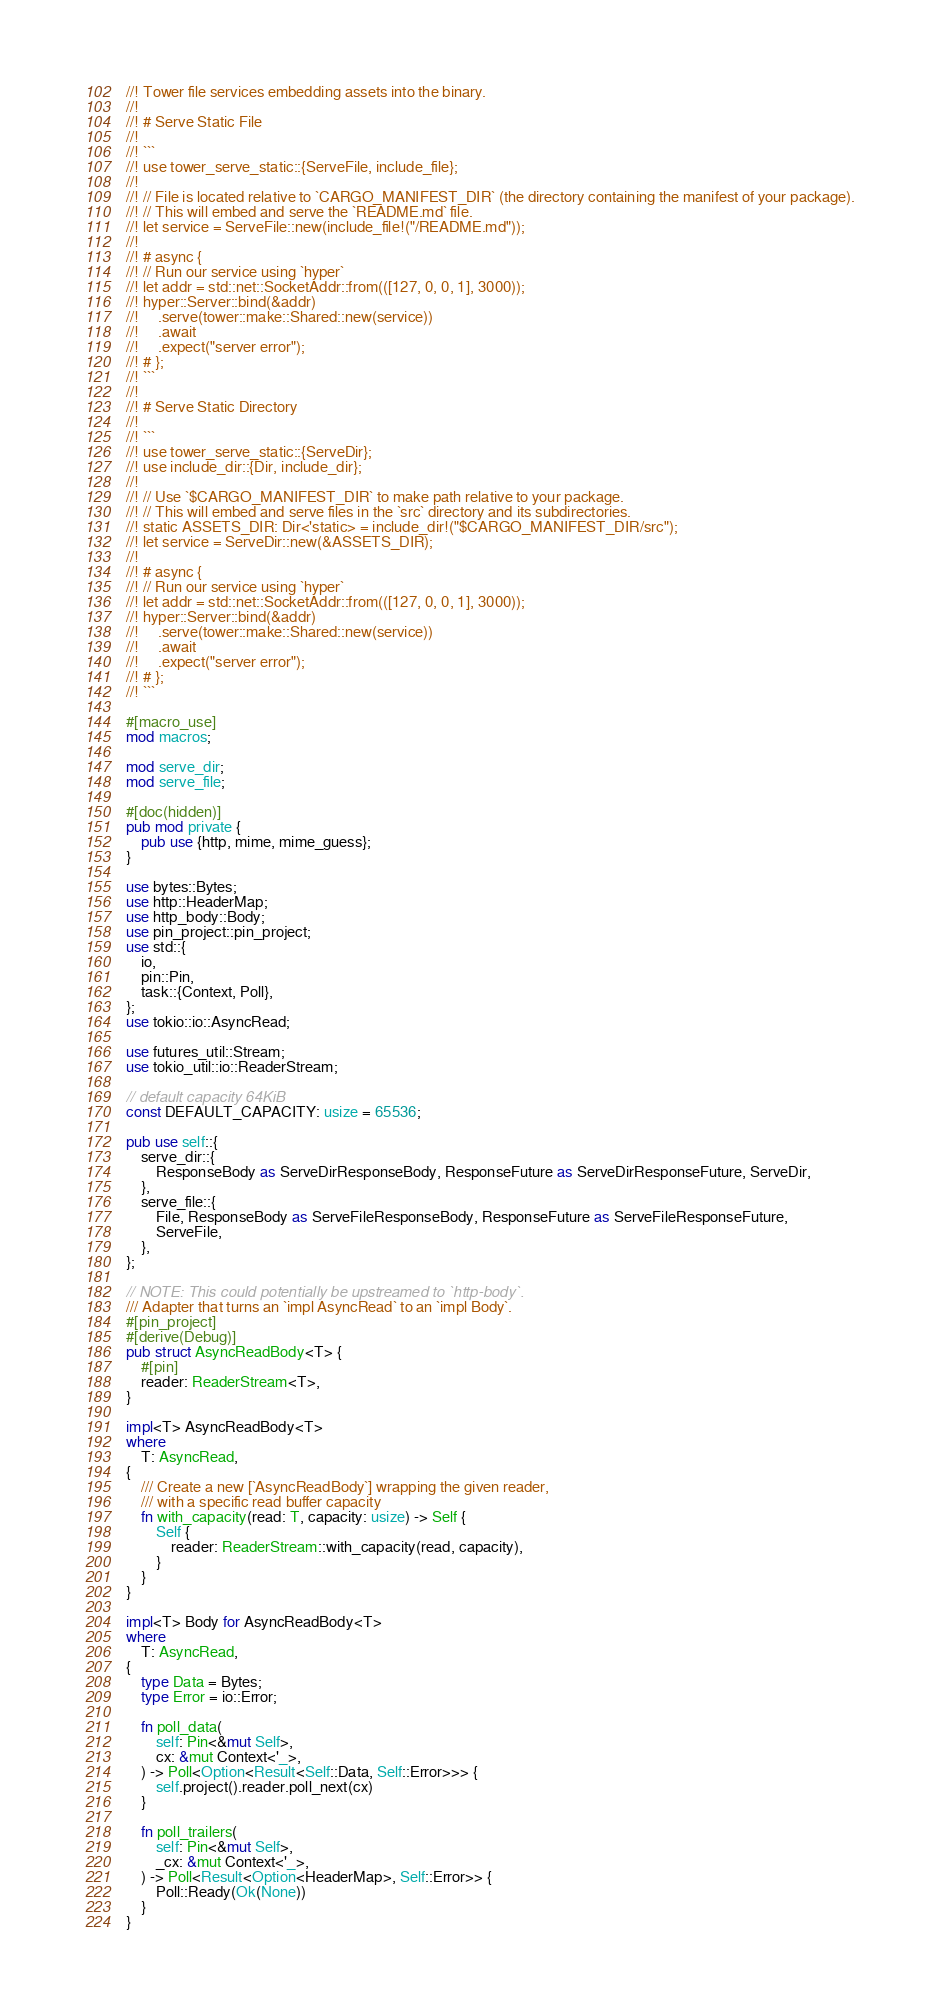Convert code to text. <code><loc_0><loc_0><loc_500><loc_500><_Rust_>//! Tower file services embedding assets into the binary.
//!
//! # Serve Static File
//!
//! ```
//! use tower_serve_static::{ServeFile, include_file};
//!
//! // File is located relative to `CARGO_MANIFEST_DIR` (the directory containing the manifest of your package).
//! // This will embed and serve the `README.md` file.
//! let service = ServeFile::new(include_file!("/README.md"));
//!
//! # async {
//! // Run our service using `hyper`
//! let addr = std::net::SocketAddr::from(([127, 0, 0, 1], 3000));
//! hyper::Server::bind(&addr)
//!     .serve(tower::make::Shared::new(service))
//!     .await
//!     .expect("server error");
//! # };
//! ```
//!
//! # Serve Static Directory
//!
//! ```
//! use tower_serve_static::{ServeDir};
//! use include_dir::{Dir, include_dir};
//!
//! // Use `$CARGO_MANIFEST_DIR` to make path relative to your package.
//! // This will embed and serve files in the `src` directory and its subdirectories.
//! static ASSETS_DIR: Dir<'static> = include_dir!("$CARGO_MANIFEST_DIR/src");
//! let service = ServeDir::new(&ASSETS_DIR);
//!
//! # async {
//! // Run our service using `hyper`
//! let addr = std::net::SocketAddr::from(([127, 0, 0, 1], 3000));
//! hyper::Server::bind(&addr)
//!     .serve(tower::make::Shared::new(service))
//!     .await
//!     .expect("server error");
//! # };
//! ```

#[macro_use]
mod macros;

mod serve_dir;
mod serve_file;

#[doc(hidden)]
pub mod private {
    pub use {http, mime, mime_guess};
}

use bytes::Bytes;
use http::HeaderMap;
use http_body::Body;
use pin_project::pin_project;
use std::{
    io,
    pin::Pin,
    task::{Context, Poll},
};
use tokio::io::AsyncRead;

use futures_util::Stream;
use tokio_util::io::ReaderStream;

// default capacity 64KiB
const DEFAULT_CAPACITY: usize = 65536;

pub use self::{
    serve_dir::{
        ResponseBody as ServeDirResponseBody, ResponseFuture as ServeDirResponseFuture, ServeDir,
    },
    serve_file::{
        File, ResponseBody as ServeFileResponseBody, ResponseFuture as ServeFileResponseFuture,
        ServeFile,
    },
};

// NOTE: This could potentially be upstreamed to `http-body`.
/// Adapter that turns an `impl AsyncRead` to an `impl Body`.
#[pin_project]
#[derive(Debug)]
pub struct AsyncReadBody<T> {
    #[pin]
    reader: ReaderStream<T>,
}

impl<T> AsyncReadBody<T>
where
    T: AsyncRead,
{
    /// Create a new [`AsyncReadBody`] wrapping the given reader,
    /// with a specific read buffer capacity
    fn with_capacity(read: T, capacity: usize) -> Self {
        Self {
            reader: ReaderStream::with_capacity(read, capacity),
        }
    }
}

impl<T> Body for AsyncReadBody<T>
where
    T: AsyncRead,
{
    type Data = Bytes;
    type Error = io::Error;

    fn poll_data(
        self: Pin<&mut Self>,
        cx: &mut Context<'_>,
    ) -> Poll<Option<Result<Self::Data, Self::Error>>> {
        self.project().reader.poll_next(cx)
    }

    fn poll_trailers(
        self: Pin<&mut Self>,
        _cx: &mut Context<'_>,
    ) -> Poll<Result<Option<HeaderMap>, Self::Error>> {
        Poll::Ready(Ok(None))
    }
}
</code> 